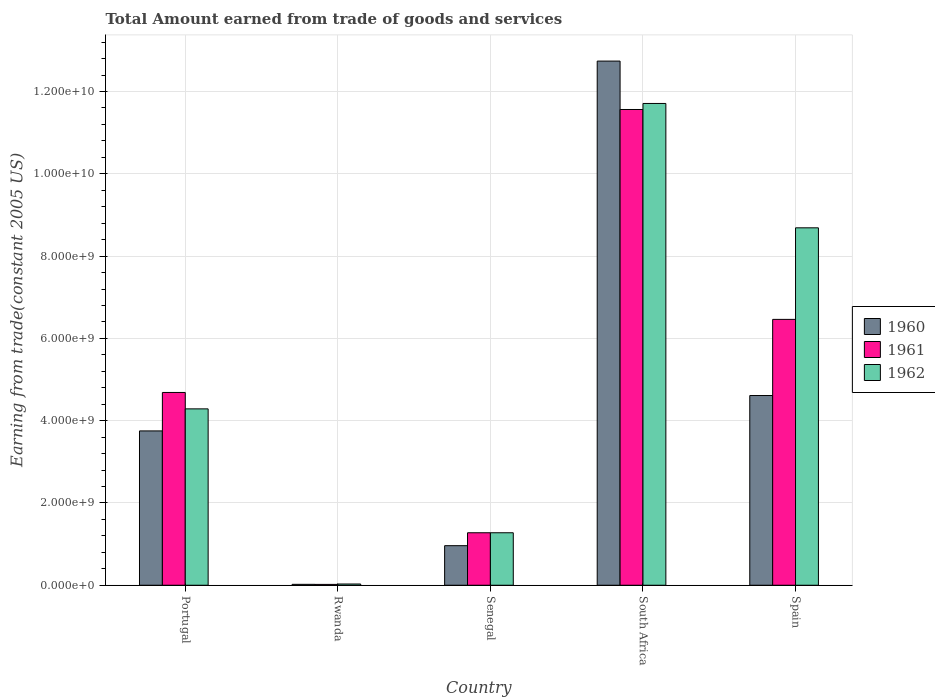How many groups of bars are there?
Make the answer very short. 5. Are the number of bars per tick equal to the number of legend labels?
Ensure brevity in your answer.  Yes. How many bars are there on the 5th tick from the left?
Your answer should be compact. 3. What is the total amount earned by trading goods and services in 1960 in Spain?
Provide a succinct answer. 4.61e+09. Across all countries, what is the maximum total amount earned by trading goods and services in 1962?
Keep it short and to the point. 1.17e+1. Across all countries, what is the minimum total amount earned by trading goods and services in 1962?
Provide a short and direct response. 2.97e+07. In which country was the total amount earned by trading goods and services in 1961 maximum?
Offer a very short reply. South Africa. In which country was the total amount earned by trading goods and services in 1962 minimum?
Provide a succinct answer. Rwanda. What is the total total amount earned by trading goods and services in 1961 in the graph?
Offer a very short reply. 2.40e+1. What is the difference between the total amount earned by trading goods and services in 1962 in South Africa and that in Spain?
Your response must be concise. 3.02e+09. What is the difference between the total amount earned by trading goods and services in 1960 in Rwanda and the total amount earned by trading goods and services in 1962 in Spain?
Give a very brief answer. -8.67e+09. What is the average total amount earned by trading goods and services in 1962 per country?
Offer a terse response. 5.20e+09. What is the difference between the total amount earned by trading goods and services of/in 1962 and total amount earned by trading goods and services of/in 1961 in South Africa?
Your response must be concise. 1.46e+08. In how many countries, is the total amount earned by trading goods and services in 1960 greater than 11200000000 US$?
Keep it short and to the point. 1. What is the ratio of the total amount earned by trading goods and services in 1961 in Portugal to that in Rwanda?
Make the answer very short. 228.56. Is the difference between the total amount earned by trading goods and services in 1962 in Rwanda and South Africa greater than the difference between the total amount earned by trading goods and services in 1961 in Rwanda and South Africa?
Ensure brevity in your answer.  No. What is the difference between the highest and the second highest total amount earned by trading goods and services in 1961?
Your answer should be very brief. 1.78e+09. What is the difference between the highest and the lowest total amount earned by trading goods and services in 1962?
Offer a terse response. 1.17e+1. In how many countries, is the total amount earned by trading goods and services in 1962 greater than the average total amount earned by trading goods and services in 1962 taken over all countries?
Provide a short and direct response. 2. What does the 2nd bar from the left in Rwanda represents?
Offer a very short reply. 1961. Is it the case that in every country, the sum of the total amount earned by trading goods and services in 1961 and total amount earned by trading goods and services in 1962 is greater than the total amount earned by trading goods and services in 1960?
Provide a short and direct response. Yes. How many bars are there?
Offer a very short reply. 15. Are all the bars in the graph horizontal?
Your answer should be very brief. No. How many countries are there in the graph?
Your response must be concise. 5. What is the difference between two consecutive major ticks on the Y-axis?
Offer a terse response. 2.00e+09. Does the graph contain grids?
Ensure brevity in your answer.  Yes. Where does the legend appear in the graph?
Make the answer very short. Center right. How many legend labels are there?
Provide a short and direct response. 3. What is the title of the graph?
Your response must be concise. Total Amount earned from trade of goods and services. Does "1961" appear as one of the legend labels in the graph?
Make the answer very short. Yes. What is the label or title of the X-axis?
Keep it short and to the point. Country. What is the label or title of the Y-axis?
Provide a succinct answer. Earning from trade(constant 2005 US). What is the Earning from trade(constant 2005 US) in 1960 in Portugal?
Offer a terse response. 3.75e+09. What is the Earning from trade(constant 2005 US) of 1961 in Portugal?
Offer a terse response. 4.69e+09. What is the Earning from trade(constant 2005 US) of 1962 in Portugal?
Provide a succinct answer. 4.29e+09. What is the Earning from trade(constant 2005 US) in 1960 in Rwanda?
Provide a succinct answer. 2.20e+07. What is the Earning from trade(constant 2005 US) in 1961 in Rwanda?
Make the answer very short. 2.05e+07. What is the Earning from trade(constant 2005 US) in 1962 in Rwanda?
Provide a short and direct response. 2.97e+07. What is the Earning from trade(constant 2005 US) of 1960 in Senegal?
Provide a succinct answer. 9.62e+08. What is the Earning from trade(constant 2005 US) of 1961 in Senegal?
Your answer should be very brief. 1.28e+09. What is the Earning from trade(constant 2005 US) of 1962 in Senegal?
Offer a terse response. 1.28e+09. What is the Earning from trade(constant 2005 US) in 1960 in South Africa?
Offer a very short reply. 1.27e+1. What is the Earning from trade(constant 2005 US) in 1961 in South Africa?
Make the answer very short. 1.16e+1. What is the Earning from trade(constant 2005 US) in 1962 in South Africa?
Ensure brevity in your answer.  1.17e+1. What is the Earning from trade(constant 2005 US) in 1960 in Spain?
Give a very brief answer. 4.61e+09. What is the Earning from trade(constant 2005 US) of 1961 in Spain?
Your answer should be compact. 6.46e+09. What is the Earning from trade(constant 2005 US) of 1962 in Spain?
Ensure brevity in your answer.  8.69e+09. Across all countries, what is the maximum Earning from trade(constant 2005 US) in 1960?
Your response must be concise. 1.27e+1. Across all countries, what is the maximum Earning from trade(constant 2005 US) of 1961?
Offer a terse response. 1.16e+1. Across all countries, what is the maximum Earning from trade(constant 2005 US) of 1962?
Provide a short and direct response. 1.17e+1. Across all countries, what is the minimum Earning from trade(constant 2005 US) of 1960?
Keep it short and to the point. 2.20e+07. Across all countries, what is the minimum Earning from trade(constant 2005 US) in 1961?
Provide a succinct answer. 2.05e+07. Across all countries, what is the minimum Earning from trade(constant 2005 US) in 1962?
Ensure brevity in your answer.  2.97e+07. What is the total Earning from trade(constant 2005 US) of 1960 in the graph?
Provide a short and direct response. 2.21e+1. What is the total Earning from trade(constant 2005 US) of 1961 in the graph?
Make the answer very short. 2.40e+1. What is the total Earning from trade(constant 2005 US) of 1962 in the graph?
Offer a very short reply. 2.60e+1. What is the difference between the Earning from trade(constant 2005 US) of 1960 in Portugal and that in Rwanda?
Offer a very short reply. 3.73e+09. What is the difference between the Earning from trade(constant 2005 US) of 1961 in Portugal and that in Rwanda?
Offer a very short reply. 4.67e+09. What is the difference between the Earning from trade(constant 2005 US) of 1962 in Portugal and that in Rwanda?
Provide a short and direct response. 4.26e+09. What is the difference between the Earning from trade(constant 2005 US) in 1960 in Portugal and that in Senegal?
Give a very brief answer. 2.79e+09. What is the difference between the Earning from trade(constant 2005 US) in 1961 in Portugal and that in Senegal?
Keep it short and to the point. 3.41e+09. What is the difference between the Earning from trade(constant 2005 US) of 1962 in Portugal and that in Senegal?
Your answer should be very brief. 3.01e+09. What is the difference between the Earning from trade(constant 2005 US) of 1960 in Portugal and that in South Africa?
Keep it short and to the point. -8.99e+09. What is the difference between the Earning from trade(constant 2005 US) in 1961 in Portugal and that in South Africa?
Your response must be concise. -6.88e+09. What is the difference between the Earning from trade(constant 2005 US) in 1962 in Portugal and that in South Africa?
Ensure brevity in your answer.  -7.42e+09. What is the difference between the Earning from trade(constant 2005 US) of 1960 in Portugal and that in Spain?
Keep it short and to the point. -8.60e+08. What is the difference between the Earning from trade(constant 2005 US) in 1961 in Portugal and that in Spain?
Make the answer very short. -1.78e+09. What is the difference between the Earning from trade(constant 2005 US) in 1962 in Portugal and that in Spain?
Your answer should be compact. -4.40e+09. What is the difference between the Earning from trade(constant 2005 US) of 1960 in Rwanda and that in Senegal?
Keep it short and to the point. -9.40e+08. What is the difference between the Earning from trade(constant 2005 US) of 1961 in Rwanda and that in Senegal?
Provide a short and direct response. -1.26e+09. What is the difference between the Earning from trade(constant 2005 US) in 1962 in Rwanda and that in Senegal?
Your response must be concise. -1.25e+09. What is the difference between the Earning from trade(constant 2005 US) of 1960 in Rwanda and that in South Africa?
Your answer should be compact. -1.27e+1. What is the difference between the Earning from trade(constant 2005 US) in 1961 in Rwanda and that in South Africa?
Provide a short and direct response. -1.15e+1. What is the difference between the Earning from trade(constant 2005 US) in 1962 in Rwanda and that in South Africa?
Offer a very short reply. -1.17e+1. What is the difference between the Earning from trade(constant 2005 US) of 1960 in Rwanda and that in Spain?
Your answer should be very brief. -4.59e+09. What is the difference between the Earning from trade(constant 2005 US) in 1961 in Rwanda and that in Spain?
Your response must be concise. -6.44e+09. What is the difference between the Earning from trade(constant 2005 US) in 1962 in Rwanda and that in Spain?
Your response must be concise. -8.66e+09. What is the difference between the Earning from trade(constant 2005 US) of 1960 in Senegal and that in South Africa?
Make the answer very short. -1.18e+1. What is the difference between the Earning from trade(constant 2005 US) in 1961 in Senegal and that in South Africa?
Make the answer very short. -1.03e+1. What is the difference between the Earning from trade(constant 2005 US) in 1962 in Senegal and that in South Africa?
Provide a succinct answer. -1.04e+1. What is the difference between the Earning from trade(constant 2005 US) in 1960 in Senegal and that in Spain?
Your answer should be very brief. -3.65e+09. What is the difference between the Earning from trade(constant 2005 US) of 1961 in Senegal and that in Spain?
Provide a succinct answer. -5.19e+09. What is the difference between the Earning from trade(constant 2005 US) in 1962 in Senegal and that in Spain?
Offer a terse response. -7.41e+09. What is the difference between the Earning from trade(constant 2005 US) of 1960 in South Africa and that in Spain?
Keep it short and to the point. 8.13e+09. What is the difference between the Earning from trade(constant 2005 US) of 1961 in South Africa and that in Spain?
Your answer should be very brief. 5.10e+09. What is the difference between the Earning from trade(constant 2005 US) in 1962 in South Africa and that in Spain?
Give a very brief answer. 3.02e+09. What is the difference between the Earning from trade(constant 2005 US) in 1960 in Portugal and the Earning from trade(constant 2005 US) in 1961 in Rwanda?
Ensure brevity in your answer.  3.73e+09. What is the difference between the Earning from trade(constant 2005 US) in 1960 in Portugal and the Earning from trade(constant 2005 US) in 1962 in Rwanda?
Give a very brief answer. 3.72e+09. What is the difference between the Earning from trade(constant 2005 US) of 1961 in Portugal and the Earning from trade(constant 2005 US) of 1962 in Rwanda?
Your answer should be very brief. 4.66e+09. What is the difference between the Earning from trade(constant 2005 US) of 1960 in Portugal and the Earning from trade(constant 2005 US) of 1961 in Senegal?
Offer a very short reply. 2.48e+09. What is the difference between the Earning from trade(constant 2005 US) of 1960 in Portugal and the Earning from trade(constant 2005 US) of 1962 in Senegal?
Keep it short and to the point. 2.48e+09. What is the difference between the Earning from trade(constant 2005 US) of 1961 in Portugal and the Earning from trade(constant 2005 US) of 1962 in Senegal?
Offer a terse response. 3.41e+09. What is the difference between the Earning from trade(constant 2005 US) of 1960 in Portugal and the Earning from trade(constant 2005 US) of 1961 in South Africa?
Offer a very short reply. -7.81e+09. What is the difference between the Earning from trade(constant 2005 US) of 1960 in Portugal and the Earning from trade(constant 2005 US) of 1962 in South Africa?
Give a very brief answer. -7.96e+09. What is the difference between the Earning from trade(constant 2005 US) in 1961 in Portugal and the Earning from trade(constant 2005 US) in 1962 in South Africa?
Your answer should be compact. -7.02e+09. What is the difference between the Earning from trade(constant 2005 US) in 1960 in Portugal and the Earning from trade(constant 2005 US) in 1961 in Spain?
Your answer should be very brief. -2.71e+09. What is the difference between the Earning from trade(constant 2005 US) in 1960 in Portugal and the Earning from trade(constant 2005 US) in 1962 in Spain?
Provide a succinct answer. -4.94e+09. What is the difference between the Earning from trade(constant 2005 US) in 1961 in Portugal and the Earning from trade(constant 2005 US) in 1962 in Spain?
Offer a very short reply. -4.00e+09. What is the difference between the Earning from trade(constant 2005 US) in 1960 in Rwanda and the Earning from trade(constant 2005 US) in 1961 in Senegal?
Provide a short and direct response. -1.25e+09. What is the difference between the Earning from trade(constant 2005 US) of 1960 in Rwanda and the Earning from trade(constant 2005 US) of 1962 in Senegal?
Keep it short and to the point. -1.25e+09. What is the difference between the Earning from trade(constant 2005 US) in 1961 in Rwanda and the Earning from trade(constant 2005 US) in 1962 in Senegal?
Your answer should be very brief. -1.26e+09. What is the difference between the Earning from trade(constant 2005 US) of 1960 in Rwanda and the Earning from trade(constant 2005 US) of 1961 in South Africa?
Offer a very short reply. -1.15e+1. What is the difference between the Earning from trade(constant 2005 US) in 1960 in Rwanda and the Earning from trade(constant 2005 US) in 1962 in South Africa?
Ensure brevity in your answer.  -1.17e+1. What is the difference between the Earning from trade(constant 2005 US) in 1961 in Rwanda and the Earning from trade(constant 2005 US) in 1962 in South Africa?
Make the answer very short. -1.17e+1. What is the difference between the Earning from trade(constant 2005 US) in 1960 in Rwanda and the Earning from trade(constant 2005 US) in 1961 in Spain?
Your answer should be compact. -6.44e+09. What is the difference between the Earning from trade(constant 2005 US) of 1960 in Rwanda and the Earning from trade(constant 2005 US) of 1962 in Spain?
Ensure brevity in your answer.  -8.67e+09. What is the difference between the Earning from trade(constant 2005 US) in 1961 in Rwanda and the Earning from trade(constant 2005 US) in 1962 in Spain?
Provide a succinct answer. -8.67e+09. What is the difference between the Earning from trade(constant 2005 US) of 1960 in Senegal and the Earning from trade(constant 2005 US) of 1961 in South Africa?
Offer a terse response. -1.06e+1. What is the difference between the Earning from trade(constant 2005 US) of 1960 in Senegal and the Earning from trade(constant 2005 US) of 1962 in South Africa?
Keep it short and to the point. -1.07e+1. What is the difference between the Earning from trade(constant 2005 US) in 1961 in Senegal and the Earning from trade(constant 2005 US) in 1962 in South Africa?
Give a very brief answer. -1.04e+1. What is the difference between the Earning from trade(constant 2005 US) in 1960 in Senegal and the Earning from trade(constant 2005 US) in 1961 in Spain?
Your answer should be compact. -5.50e+09. What is the difference between the Earning from trade(constant 2005 US) in 1960 in Senegal and the Earning from trade(constant 2005 US) in 1962 in Spain?
Keep it short and to the point. -7.73e+09. What is the difference between the Earning from trade(constant 2005 US) in 1961 in Senegal and the Earning from trade(constant 2005 US) in 1962 in Spain?
Keep it short and to the point. -7.41e+09. What is the difference between the Earning from trade(constant 2005 US) of 1960 in South Africa and the Earning from trade(constant 2005 US) of 1961 in Spain?
Provide a short and direct response. 6.28e+09. What is the difference between the Earning from trade(constant 2005 US) in 1960 in South Africa and the Earning from trade(constant 2005 US) in 1962 in Spain?
Offer a terse response. 4.05e+09. What is the difference between the Earning from trade(constant 2005 US) in 1961 in South Africa and the Earning from trade(constant 2005 US) in 1962 in Spain?
Offer a terse response. 2.88e+09. What is the average Earning from trade(constant 2005 US) in 1960 per country?
Ensure brevity in your answer.  4.42e+09. What is the average Earning from trade(constant 2005 US) of 1961 per country?
Your answer should be compact. 4.80e+09. What is the average Earning from trade(constant 2005 US) in 1962 per country?
Your response must be concise. 5.20e+09. What is the difference between the Earning from trade(constant 2005 US) in 1960 and Earning from trade(constant 2005 US) in 1961 in Portugal?
Give a very brief answer. -9.35e+08. What is the difference between the Earning from trade(constant 2005 US) of 1960 and Earning from trade(constant 2005 US) of 1962 in Portugal?
Offer a very short reply. -5.36e+08. What is the difference between the Earning from trade(constant 2005 US) of 1961 and Earning from trade(constant 2005 US) of 1962 in Portugal?
Give a very brief answer. 3.99e+08. What is the difference between the Earning from trade(constant 2005 US) in 1960 and Earning from trade(constant 2005 US) in 1961 in Rwanda?
Give a very brief answer. 1.46e+06. What is the difference between the Earning from trade(constant 2005 US) of 1960 and Earning from trade(constant 2005 US) of 1962 in Rwanda?
Provide a succinct answer. -7.74e+06. What is the difference between the Earning from trade(constant 2005 US) in 1961 and Earning from trade(constant 2005 US) in 1962 in Rwanda?
Your answer should be very brief. -9.20e+06. What is the difference between the Earning from trade(constant 2005 US) in 1960 and Earning from trade(constant 2005 US) in 1961 in Senegal?
Make the answer very short. -3.14e+08. What is the difference between the Earning from trade(constant 2005 US) in 1960 and Earning from trade(constant 2005 US) in 1962 in Senegal?
Provide a short and direct response. -3.14e+08. What is the difference between the Earning from trade(constant 2005 US) in 1960 and Earning from trade(constant 2005 US) in 1961 in South Africa?
Your answer should be very brief. 1.18e+09. What is the difference between the Earning from trade(constant 2005 US) of 1960 and Earning from trade(constant 2005 US) of 1962 in South Africa?
Your answer should be compact. 1.03e+09. What is the difference between the Earning from trade(constant 2005 US) in 1961 and Earning from trade(constant 2005 US) in 1962 in South Africa?
Keep it short and to the point. -1.46e+08. What is the difference between the Earning from trade(constant 2005 US) in 1960 and Earning from trade(constant 2005 US) in 1961 in Spain?
Your response must be concise. -1.85e+09. What is the difference between the Earning from trade(constant 2005 US) in 1960 and Earning from trade(constant 2005 US) in 1962 in Spain?
Make the answer very short. -4.08e+09. What is the difference between the Earning from trade(constant 2005 US) of 1961 and Earning from trade(constant 2005 US) of 1962 in Spain?
Keep it short and to the point. -2.23e+09. What is the ratio of the Earning from trade(constant 2005 US) in 1960 in Portugal to that in Rwanda?
Give a very brief answer. 170.8. What is the ratio of the Earning from trade(constant 2005 US) in 1961 in Portugal to that in Rwanda?
Offer a terse response. 228.56. What is the ratio of the Earning from trade(constant 2005 US) of 1962 in Portugal to that in Rwanda?
Provide a short and direct response. 144.33. What is the ratio of the Earning from trade(constant 2005 US) of 1960 in Portugal to that in Senegal?
Keep it short and to the point. 3.9. What is the ratio of the Earning from trade(constant 2005 US) of 1961 in Portugal to that in Senegal?
Ensure brevity in your answer.  3.67. What is the ratio of the Earning from trade(constant 2005 US) in 1962 in Portugal to that in Senegal?
Offer a very short reply. 3.36. What is the ratio of the Earning from trade(constant 2005 US) in 1960 in Portugal to that in South Africa?
Offer a terse response. 0.29. What is the ratio of the Earning from trade(constant 2005 US) in 1961 in Portugal to that in South Africa?
Offer a terse response. 0.41. What is the ratio of the Earning from trade(constant 2005 US) in 1962 in Portugal to that in South Africa?
Provide a short and direct response. 0.37. What is the ratio of the Earning from trade(constant 2005 US) of 1960 in Portugal to that in Spain?
Provide a succinct answer. 0.81. What is the ratio of the Earning from trade(constant 2005 US) in 1961 in Portugal to that in Spain?
Offer a very short reply. 0.73. What is the ratio of the Earning from trade(constant 2005 US) of 1962 in Portugal to that in Spain?
Provide a short and direct response. 0.49. What is the ratio of the Earning from trade(constant 2005 US) of 1960 in Rwanda to that in Senegal?
Your answer should be very brief. 0.02. What is the ratio of the Earning from trade(constant 2005 US) in 1961 in Rwanda to that in Senegal?
Ensure brevity in your answer.  0.02. What is the ratio of the Earning from trade(constant 2005 US) of 1962 in Rwanda to that in Senegal?
Provide a short and direct response. 0.02. What is the ratio of the Earning from trade(constant 2005 US) in 1960 in Rwanda to that in South Africa?
Your answer should be compact. 0. What is the ratio of the Earning from trade(constant 2005 US) in 1961 in Rwanda to that in South Africa?
Your answer should be compact. 0. What is the ratio of the Earning from trade(constant 2005 US) in 1962 in Rwanda to that in South Africa?
Give a very brief answer. 0. What is the ratio of the Earning from trade(constant 2005 US) in 1960 in Rwanda to that in Spain?
Give a very brief answer. 0. What is the ratio of the Earning from trade(constant 2005 US) in 1961 in Rwanda to that in Spain?
Provide a succinct answer. 0. What is the ratio of the Earning from trade(constant 2005 US) of 1962 in Rwanda to that in Spain?
Ensure brevity in your answer.  0. What is the ratio of the Earning from trade(constant 2005 US) of 1960 in Senegal to that in South Africa?
Your response must be concise. 0.08. What is the ratio of the Earning from trade(constant 2005 US) in 1961 in Senegal to that in South Africa?
Offer a terse response. 0.11. What is the ratio of the Earning from trade(constant 2005 US) in 1962 in Senegal to that in South Africa?
Keep it short and to the point. 0.11. What is the ratio of the Earning from trade(constant 2005 US) of 1960 in Senegal to that in Spain?
Your response must be concise. 0.21. What is the ratio of the Earning from trade(constant 2005 US) of 1961 in Senegal to that in Spain?
Make the answer very short. 0.2. What is the ratio of the Earning from trade(constant 2005 US) of 1962 in Senegal to that in Spain?
Your answer should be very brief. 0.15. What is the ratio of the Earning from trade(constant 2005 US) in 1960 in South Africa to that in Spain?
Offer a very short reply. 2.76. What is the ratio of the Earning from trade(constant 2005 US) in 1961 in South Africa to that in Spain?
Your response must be concise. 1.79. What is the ratio of the Earning from trade(constant 2005 US) in 1962 in South Africa to that in Spain?
Your answer should be compact. 1.35. What is the difference between the highest and the second highest Earning from trade(constant 2005 US) of 1960?
Provide a short and direct response. 8.13e+09. What is the difference between the highest and the second highest Earning from trade(constant 2005 US) of 1961?
Your answer should be compact. 5.10e+09. What is the difference between the highest and the second highest Earning from trade(constant 2005 US) of 1962?
Your answer should be compact. 3.02e+09. What is the difference between the highest and the lowest Earning from trade(constant 2005 US) in 1960?
Your answer should be compact. 1.27e+1. What is the difference between the highest and the lowest Earning from trade(constant 2005 US) of 1961?
Provide a short and direct response. 1.15e+1. What is the difference between the highest and the lowest Earning from trade(constant 2005 US) in 1962?
Provide a succinct answer. 1.17e+1. 